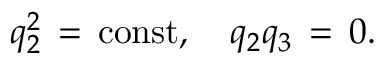Convert formula to latex. <formula><loc_0><loc_0><loc_500><loc_500>q _ { 2 } ^ { 2 } \, = \, c o n s t , \quad q _ { 2 } q _ { 3 } \, = \, 0 .</formula> 